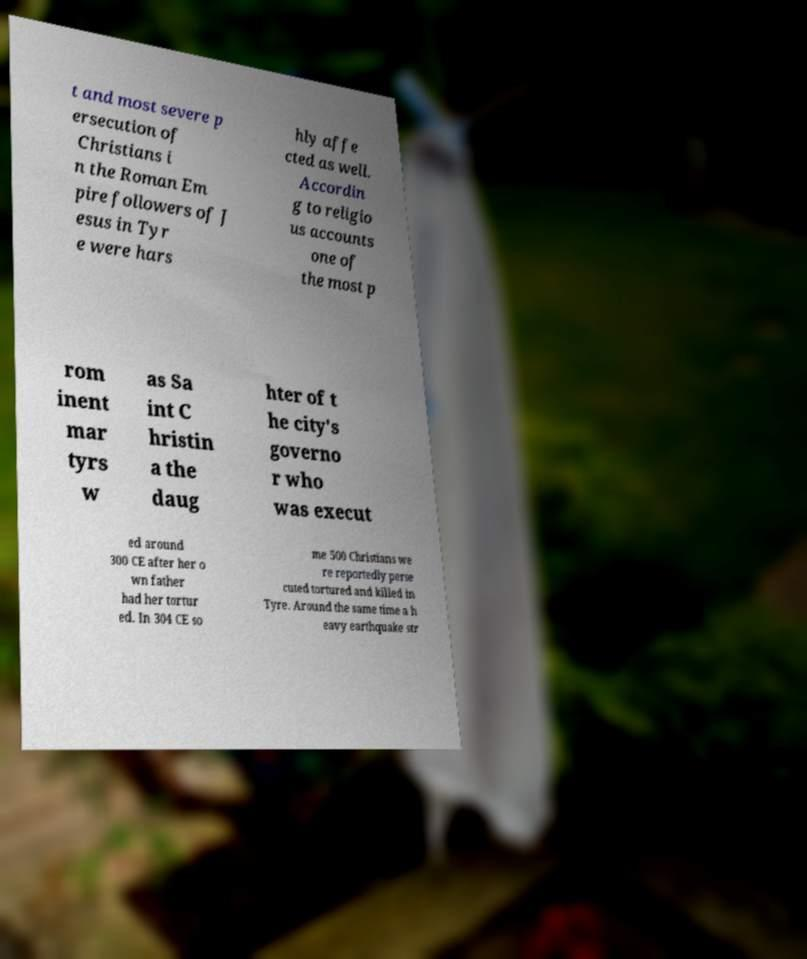Can you read and provide the text displayed in the image?This photo seems to have some interesting text. Can you extract and type it out for me? t and most severe p ersecution of Christians i n the Roman Em pire followers of J esus in Tyr e were hars hly affe cted as well. Accordin g to religio us accounts one of the most p rom inent mar tyrs w as Sa int C hristin a the daug hter of t he city's governo r who was execut ed around 300 CE after her o wn father had her tortur ed. In 304 CE so me 500 Christians we re reportedly perse cuted tortured and killed in Tyre. Around the same time a h eavy earthquake str 